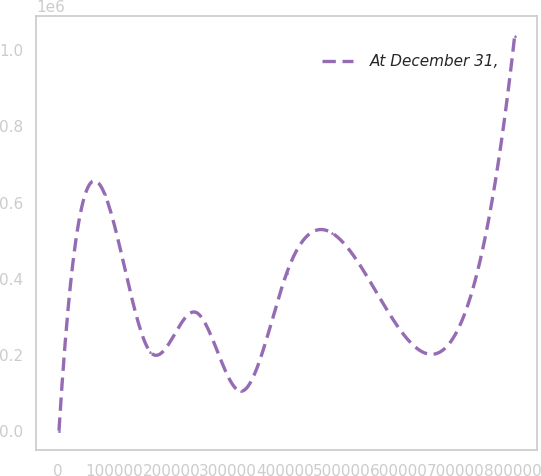<chart> <loc_0><loc_0><loc_500><loc_500><line_chart><ecel><fcel>At December 31,<nl><fcel>2315.35<fcel>1855.94<nl><fcel>82478.6<fcel>623022<nl><fcel>162642<fcel>208911<nl><fcel>242805<fcel>312439<nl><fcel>322968<fcel>105384<nl><fcel>403132<fcel>415967<nl><fcel>483295<fcel>519494<nl><fcel>803948<fcel>1.03713e+06<nl></chart> 